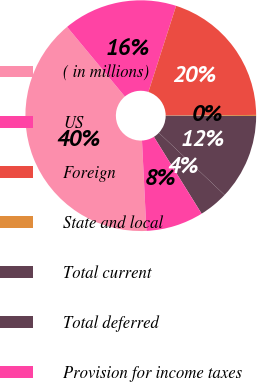<chart> <loc_0><loc_0><loc_500><loc_500><pie_chart><fcel>( in millions)<fcel>US<fcel>Foreign<fcel>State and local<fcel>Total current<fcel>Total deferred<fcel>Provision for income taxes<nl><fcel>39.75%<fcel>15.98%<fcel>19.94%<fcel>0.14%<fcel>12.02%<fcel>4.1%<fcel>8.06%<nl></chart> 